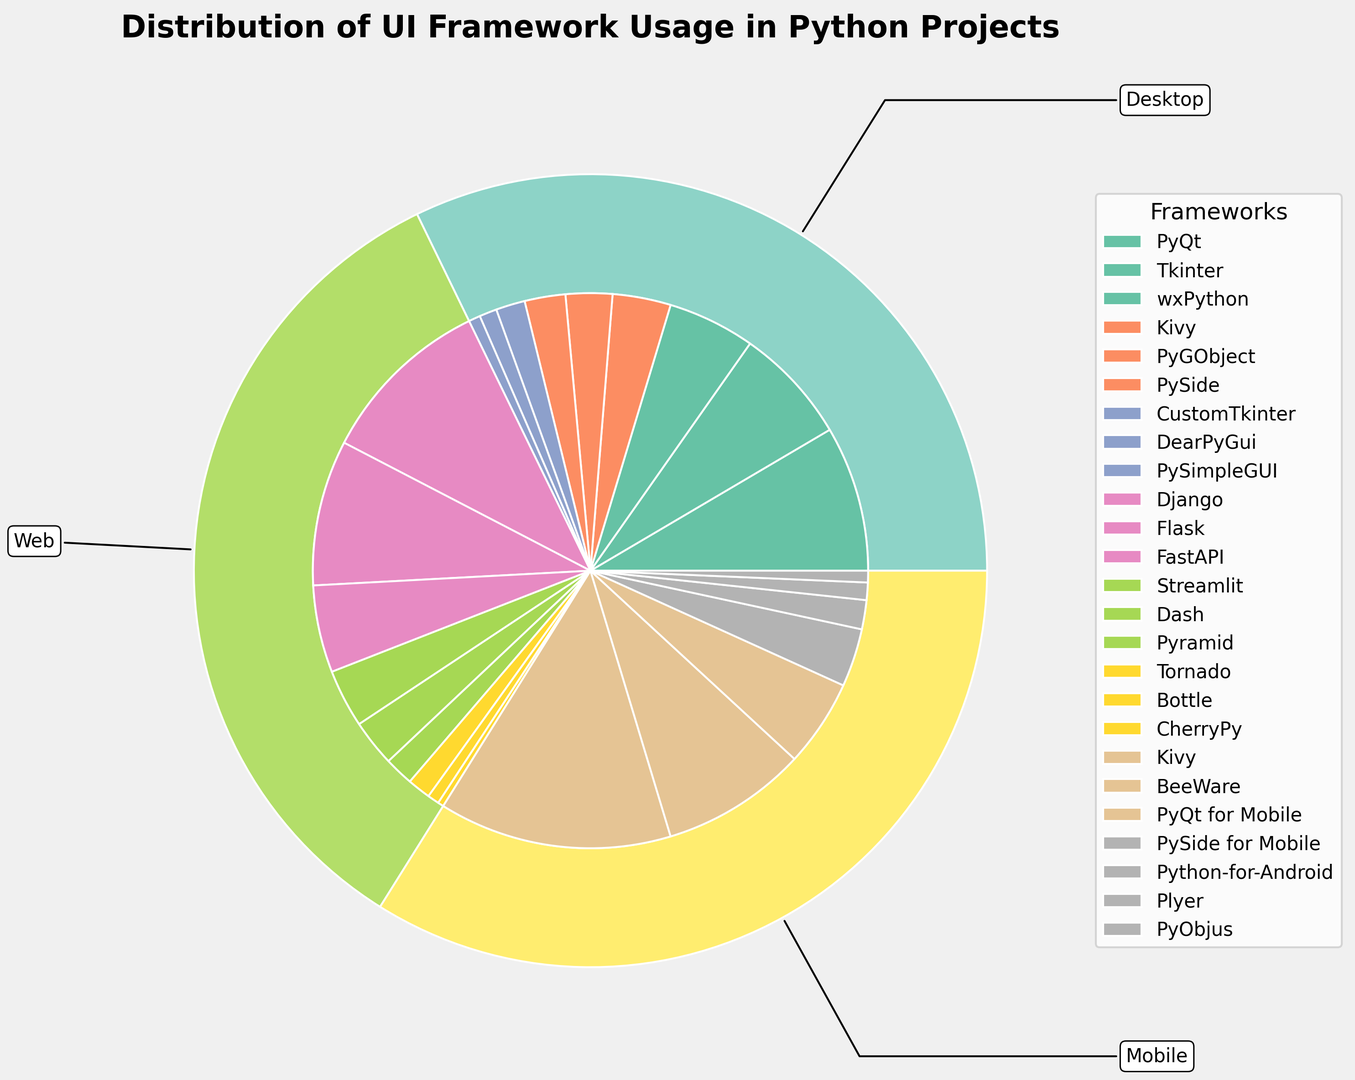What is the most used UI framework for desktop applications? Looking at the section of the pie chart labeled "Desktop," the largest segment is for PyQt.
Answer: PyQt Which category has the smallest overall percentage of usage? By comparing the sizes of the outer segments, "Mobile" appears smaller than the others.
Answer: Mobile What is the combined percentage of the two least used web UI frameworks? Tornado (4%) and CherryPy (1%) are the two least used web frameworks. Adding them gives 4% + 1% = 5%.
Answer: 5% Which mobile UI framework has the highest usage? In the "Mobile" section of the pie chart, the largest inner segment is for Kivy.
Answer: Kivy How does the usage of Django compare to that of Flask for web applications? Django has a larger segment (30%) compared to Flask (25%). Thus, Django is more used than Flask.
Answer: Django is more used What is the total percentage of desktop UI frameworks starting with the letter 'P'? Summing the percentages: PyQt (25%) + PyGObject (8%) + PySide (7%) + PySimpleGUI (2%) = 42%.
Answer: 42% How many segments in the pie chart represent a percentage less than 5%? PySimpleGUI (2%), CherryPy (1%), Plyer (3%), PyObjus (2%), Tornado (4%), Beaker (5%), DearPyGui (3%), CustomTkinter (5%). These total 8 segments.
Answer: 8 Which is the smallest single segment for any framework in the chart, and what is its percentage? CherryPy in the "Web" category has the smallest segment. Its percentage is 1%.
Answer: CherryPy, 1% What is the difference in percentage between Kivy's usage in mobile and desktop applications? Kivy usage in Mobile is 40%, and in Desktop is 10%. The difference is 40% - 10% = 30%.
Answer: 30% If you combine the usage percentages of PyQt and Kivy in all categories, what is the total percentage? PyQt (25% from Desktop + 15% from Mobile = 40%), Kivy (10% from Desktop + 40% from Mobile = 50%). The combined total is 40% + 50% = 90%.
Answer: 90% 